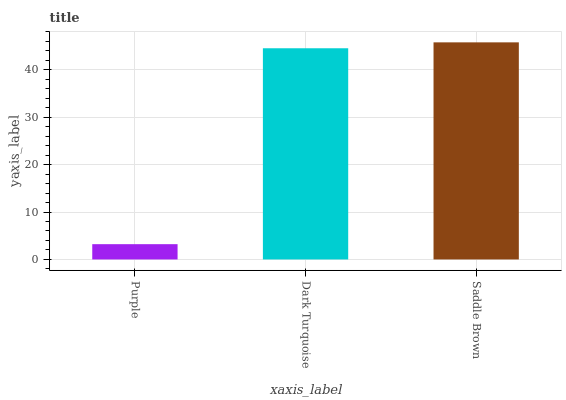Is Purple the minimum?
Answer yes or no. Yes. Is Saddle Brown the maximum?
Answer yes or no. Yes. Is Dark Turquoise the minimum?
Answer yes or no. No. Is Dark Turquoise the maximum?
Answer yes or no. No. Is Dark Turquoise greater than Purple?
Answer yes or no. Yes. Is Purple less than Dark Turquoise?
Answer yes or no. Yes. Is Purple greater than Dark Turquoise?
Answer yes or no. No. Is Dark Turquoise less than Purple?
Answer yes or no. No. Is Dark Turquoise the high median?
Answer yes or no. Yes. Is Dark Turquoise the low median?
Answer yes or no. Yes. Is Saddle Brown the high median?
Answer yes or no. No. Is Purple the low median?
Answer yes or no. No. 